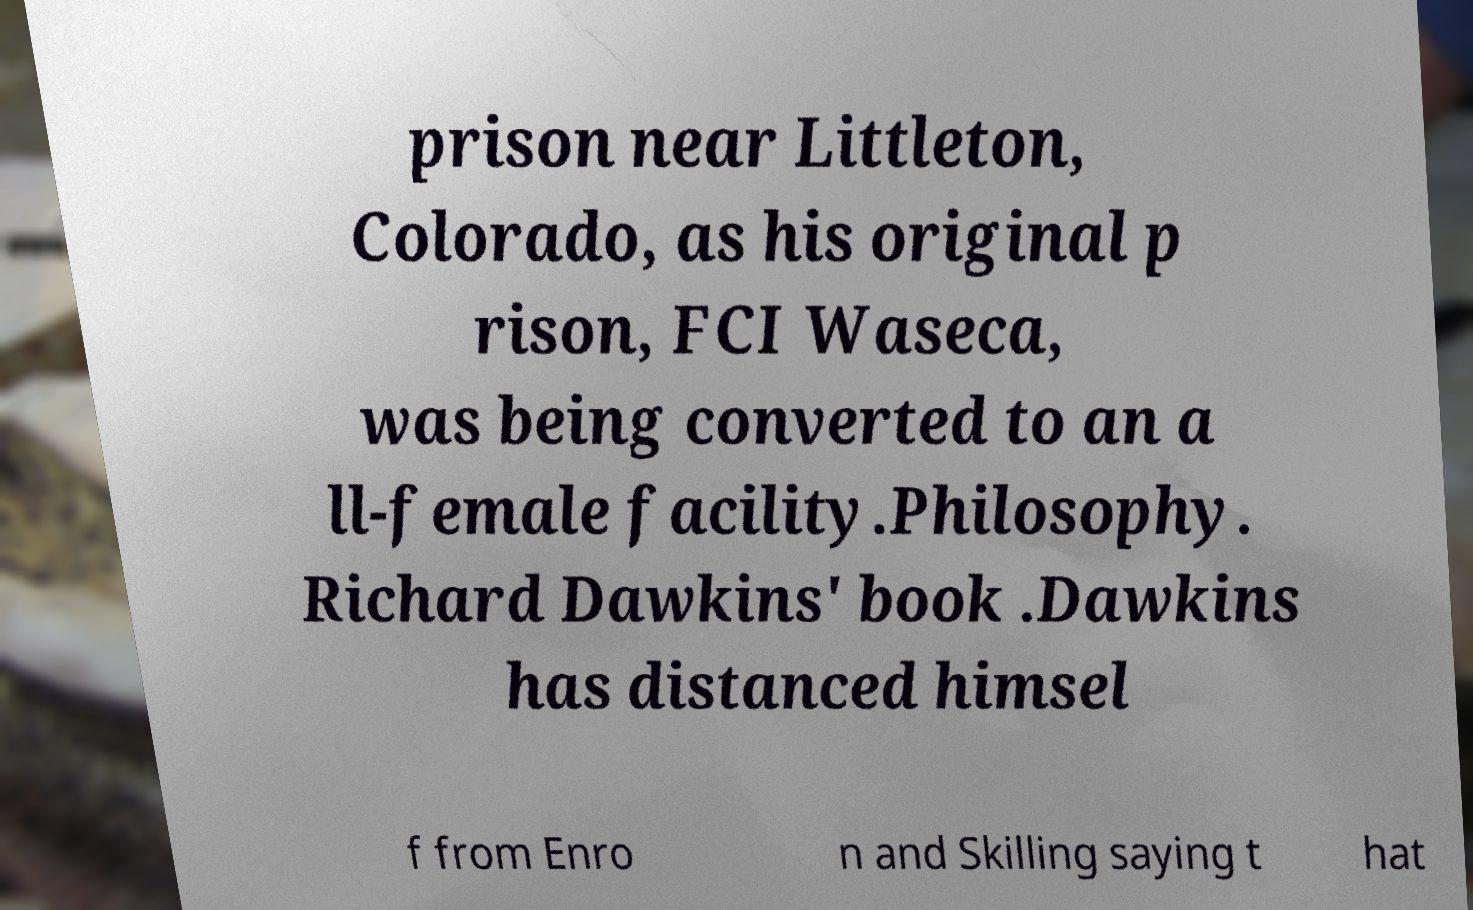Please read and relay the text visible in this image. What does it say? prison near Littleton, Colorado, as his original p rison, FCI Waseca, was being converted to an a ll-female facility.Philosophy. Richard Dawkins' book .Dawkins has distanced himsel f from Enro n and Skilling saying t hat 